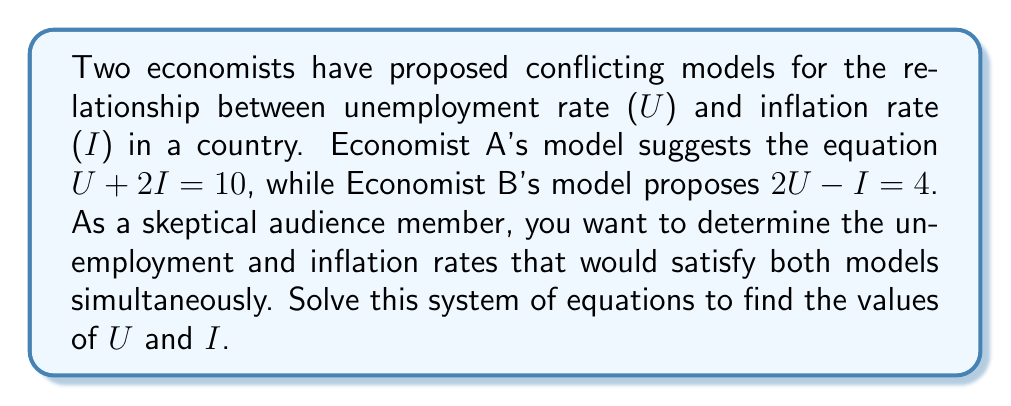Can you answer this question? Let's solve this system of linear equations step-by-step:

1) We have two equations:
   Equation 1: $U + 2I = 10$ (Economist A's model)
   Equation 2: $2U - I = 4$ (Economist B's model)

2) Let's use the substitution method. First, we'll solve Equation 1 for U:
   $U = 10 - 2I$

3) Now, substitute this expression for U into Equation 2:
   $2(10 - 2I) - I = 4$

4) Simplify:
   $20 - 4I - I = 4$
   $20 - 5I = 4$

5) Subtract 20 from both sides:
   $-5I = -16$

6) Divide both sides by -5:
   $I = 3.2$

7) Now that we know I, we can substitute this value back into either of the original equations. Let's use Equation 1:
   $U + 2(3.2) = 10$
   $U + 6.4 = 10$
   $U = 3.6$

8) Let's verify our solution satisfies both equations:
   Equation 1: $3.6 + 2(3.2) = 3.6 + 6.4 = 10$ ✓
   Equation 2: $2(3.6) - 3.2 = 7.2 - 3.2 = 4$ ✓

Therefore, the solution that satisfies both economic models is U = 3.6 and I = 3.2.
Answer: U = 3.6, I = 3.2 